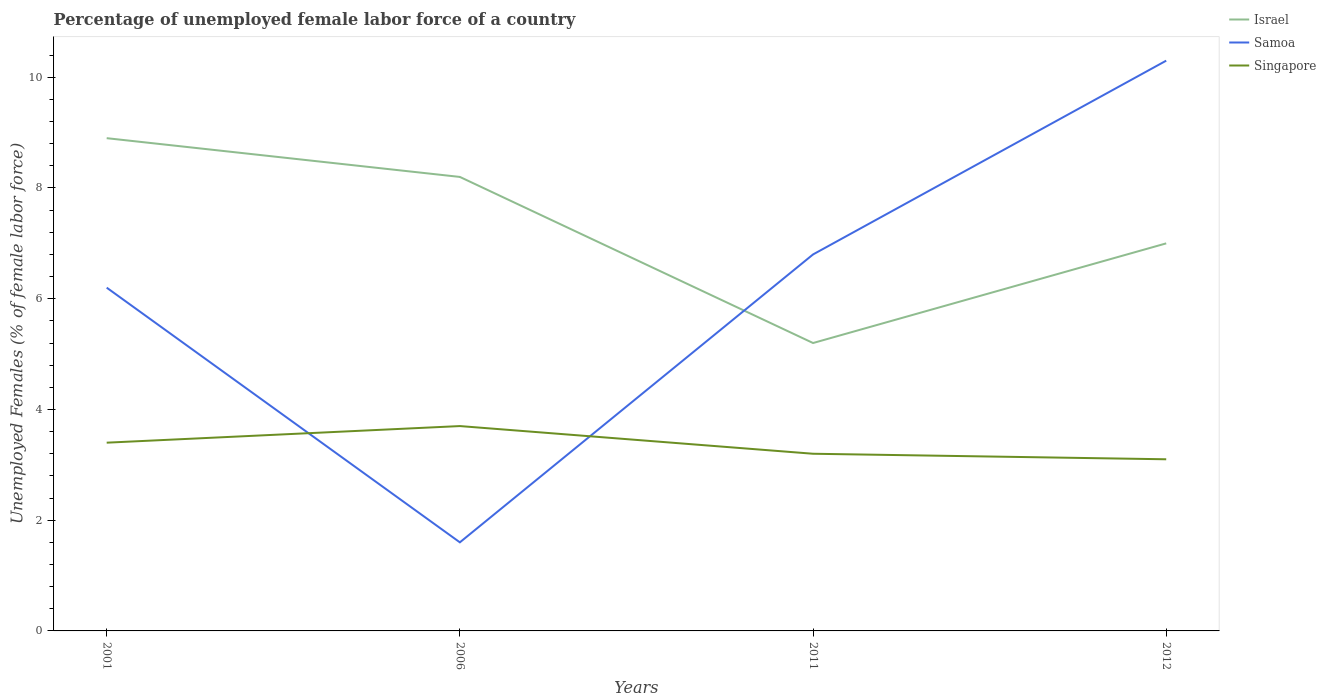How many different coloured lines are there?
Offer a very short reply. 3. Across all years, what is the maximum percentage of unemployed female labor force in Singapore?
Ensure brevity in your answer.  3.1. In which year was the percentage of unemployed female labor force in Samoa maximum?
Ensure brevity in your answer.  2006. What is the total percentage of unemployed female labor force in Singapore in the graph?
Your response must be concise. 0.6. What is the difference between the highest and the second highest percentage of unemployed female labor force in Israel?
Make the answer very short. 3.7. Are the values on the major ticks of Y-axis written in scientific E-notation?
Provide a short and direct response. No. Does the graph contain any zero values?
Provide a succinct answer. No. How are the legend labels stacked?
Offer a terse response. Vertical. What is the title of the graph?
Your answer should be very brief. Percentage of unemployed female labor force of a country. What is the label or title of the X-axis?
Provide a short and direct response. Years. What is the label or title of the Y-axis?
Your answer should be compact. Unemployed Females (% of female labor force). What is the Unemployed Females (% of female labor force) in Israel in 2001?
Keep it short and to the point. 8.9. What is the Unemployed Females (% of female labor force) in Samoa in 2001?
Offer a very short reply. 6.2. What is the Unemployed Females (% of female labor force) in Singapore in 2001?
Your response must be concise. 3.4. What is the Unemployed Females (% of female labor force) in Israel in 2006?
Give a very brief answer. 8.2. What is the Unemployed Females (% of female labor force) in Samoa in 2006?
Your answer should be compact. 1.6. What is the Unemployed Females (% of female labor force) in Singapore in 2006?
Ensure brevity in your answer.  3.7. What is the Unemployed Females (% of female labor force) of Israel in 2011?
Make the answer very short. 5.2. What is the Unemployed Females (% of female labor force) of Samoa in 2011?
Make the answer very short. 6.8. What is the Unemployed Females (% of female labor force) of Singapore in 2011?
Offer a very short reply. 3.2. What is the Unemployed Females (% of female labor force) in Israel in 2012?
Ensure brevity in your answer.  7. What is the Unemployed Females (% of female labor force) in Samoa in 2012?
Keep it short and to the point. 10.3. What is the Unemployed Females (% of female labor force) of Singapore in 2012?
Your answer should be compact. 3.1. Across all years, what is the maximum Unemployed Females (% of female labor force) in Israel?
Offer a very short reply. 8.9. Across all years, what is the maximum Unemployed Females (% of female labor force) of Samoa?
Provide a succinct answer. 10.3. Across all years, what is the maximum Unemployed Females (% of female labor force) in Singapore?
Keep it short and to the point. 3.7. Across all years, what is the minimum Unemployed Females (% of female labor force) of Israel?
Ensure brevity in your answer.  5.2. Across all years, what is the minimum Unemployed Females (% of female labor force) in Samoa?
Your answer should be compact. 1.6. Across all years, what is the minimum Unemployed Females (% of female labor force) in Singapore?
Make the answer very short. 3.1. What is the total Unemployed Females (% of female labor force) of Israel in the graph?
Give a very brief answer. 29.3. What is the total Unemployed Females (% of female labor force) in Samoa in the graph?
Provide a short and direct response. 24.9. What is the difference between the Unemployed Females (% of female labor force) of Israel in 2001 and that in 2006?
Your response must be concise. 0.7. What is the difference between the Unemployed Females (% of female labor force) of Singapore in 2001 and that in 2006?
Provide a succinct answer. -0.3. What is the difference between the Unemployed Females (% of female labor force) in Singapore in 2001 and that in 2011?
Your response must be concise. 0.2. What is the difference between the Unemployed Females (% of female labor force) in Israel in 2001 and that in 2012?
Your response must be concise. 1.9. What is the difference between the Unemployed Females (% of female labor force) in Samoa in 2001 and that in 2012?
Offer a terse response. -4.1. What is the difference between the Unemployed Females (% of female labor force) in Israel in 2006 and that in 2011?
Offer a terse response. 3. What is the difference between the Unemployed Females (% of female labor force) in Singapore in 2006 and that in 2011?
Ensure brevity in your answer.  0.5. What is the difference between the Unemployed Females (% of female labor force) in Singapore in 2006 and that in 2012?
Your response must be concise. 0.6. What is the difference between the Unemployed Females (% of female labor force) in Israel in 2011 and that in 2012?
Your response must be concise. -1.8. What is the difference between the Unemployed Females (% of female labor force) of Singapore in 2011 and that in 2012?
Your answer should be compact. 0.1. What is the difference between the Unemployed Females (% of female labor force) of Israel in 2001 and the Unemployed Females (% of female labor force) of Singapore in 2006?
Your response must be concise. 5.2. What is the difference between the Unemployed Females (% of female labor force) of Israel in 2001 and the Unemployed Females (% of female labor force) of Samoa in 2011?
Provide a succinct answer. 2.1. What is the difference between the Unemployed Females (% of female labor force) in Israel in 2001 and the Unemployed Females (% of female labor force) in Singapore in 2012?
Your answer should be compact. 5.8. What is the difference between the Unemployed Females (% of female labor force) in Samoa in 2001 and the Unemployed Females (% of female labor force) in Singapore in 2012?
Give a very brief answer. 3.1. What is the difference between the Unemployed Females (% of female labor force) in Samoa in 2006 and the Unemployed Females (% of female labor force) in Singapore in 2011?
Ensure brevity in your answer.  -1.6. What is the difference between the Unemployed Females (% of female labor force) in Israel in 2006 and the Unemployed Females (% of female labor force) in Singapore in 2012?
Provide a succinct answer. 5.1. What is the difference between the Unemployed Females (% of female labor force) of Samoa in 2006 and the Unemployed Females (% of female labor force) of Singapore in 2012?
Provide a short and direct response. -1.5. What is the difference between the Unemployed Females (% of female labor force) in Israel in 2011 and the Unemployed Females (% of female labor force) in Singapore in 2012?
Ensure brevity in your answer.  2.1. What is the average Unemployed Females (% of female labor force) of Israel per year?
Provide a short and direct response. 7.33. What is the average Unemployed Females (% of female labor force) in Samoa per year?
Your answer should be compact. 6.22. What is the average Unemployed Females (% of female labor force) of Singapore per year?
Your response must be concise. 3.35. In the year 2001, what is the difference between the Unemployed Females (% of female labor force) of Israel and Unemployed Females (% of female labor force) of Samoa?
Offer a very short reply. 2.7. In the year 2001, what is the difference between the Unemployed Females (% of female labor force) in Israel and Unemployed Females (% of female labor force) in Singapore?
Keep it short and to the point. 5.5. In the year 2001, what is the difference between the Unemployed Females (% of female labor force) of Samoa and Unemployed Females (% of female labor force) of Singapore?
Keep it short and to the point. 2.8. In the year 2006, what is the difference between the Unemployed Females (% of female labor force) of Israel and Unemployed Females (% of female labor force) of Singapore?
Keep it short and to the point. 4.5. In the year 2006, what is the difference between the Unemployed Females (% of female labor force) of Samoa and Unemployed Females (% of female labor force) of Singapore?
Your answer should be very brief. -2.1. What is the ratio of the Unemployed Females (% of female labor force) of Israel in 2001 to that in 2006?
Ensure brevity in your answer.  1.09. What is the ratio of the Unemployed Females (% of female labor force) in Samoa in 2001 to that in 2006?
Your answer should be very brief. 3.88. What is the ratio of the Unemployed Females (% of female labor force) of Singapore in 2001 to that in 2006?
Your answer should be compact. 0.92. What is the ratio of the Unemployed Females (% of female labor force) in Israel in 2001 to that in 2011?
Provide a short and direct response. 1.71. What is the ratio of the Unemployed Females (% of female labor force) in Samoa in 2001 to that in 2011?
Provide a succinct answer. 0.91. What is the ratio of the Unemployed Females (% of female labor force) in Singapore in 2001 to that in 2011?
Offer a terse response. 1.06. What is the ratio of the Unemployed Females (% of female labor force) in Israel in 2001 to that in 2012?
Offer a very short reply. 1.27. What is the ratio of the Unemployed Females (% of female labor force) in Samoa in 2001 to that in 2012?
Make the answer very short. 0.6. What is the ratio of the Unemployed Females (% of female labor force) in Singapore in 2001 to that in 2012?
Offer a very short reply. 1.1. What is the ratio of the Unemployed Females (% of female labor force) of Israel in 2006 to that in 2011?
Provide a succinct answer. 1.58. What is the ratio of the Unemployed Females (% of female labor force) in Samoa in 2006 to that in 2011?
Make the answer very short. 0.24. What is the ratio of the Unemployed Females (% of female labor force) of Singapore in 2006 to that in 2011?
Your answer should be very brief. 1.16. What is the ratio of the Unemployed Females (% of female labor force) of Israel in 2006 to that in 2012?
Make the answer very short. 1.17. What is the ratio of the Unemployed Females (% of female labor force) in Samoa in 2006 to that in 2012?
Your answer should be compact. 0.16. What is the ratio of the Unemployed Females (% of female labor force) of Singapore in 2006 to that in 2012?
Your answer should be compact. 1.19. What is the ratio of the Unemployed Females (% of female labor force) in Israel in 2011 to that in 2012?
Give a very brief answer. 0.74. What is the ratio of the Unemployed Females (% of female labor force) in Samoa in 2011 to that in 2012?
Keep it short and to the point. 0.66. What is the ratio of the Unemployed Females (% of female labor force) of Singapore in 2011 to that in 2012?
Offer a very short reply. 1.03. What is the difference between the highest and the lowest Unemployed Females (% of female labor force) in Israel?
Your response must be concise. 3.7. What is the difference between the highest and the lowest Unemployed Females (% of female labor force) of Samoa?
Offer a very short reply. 8.7. 